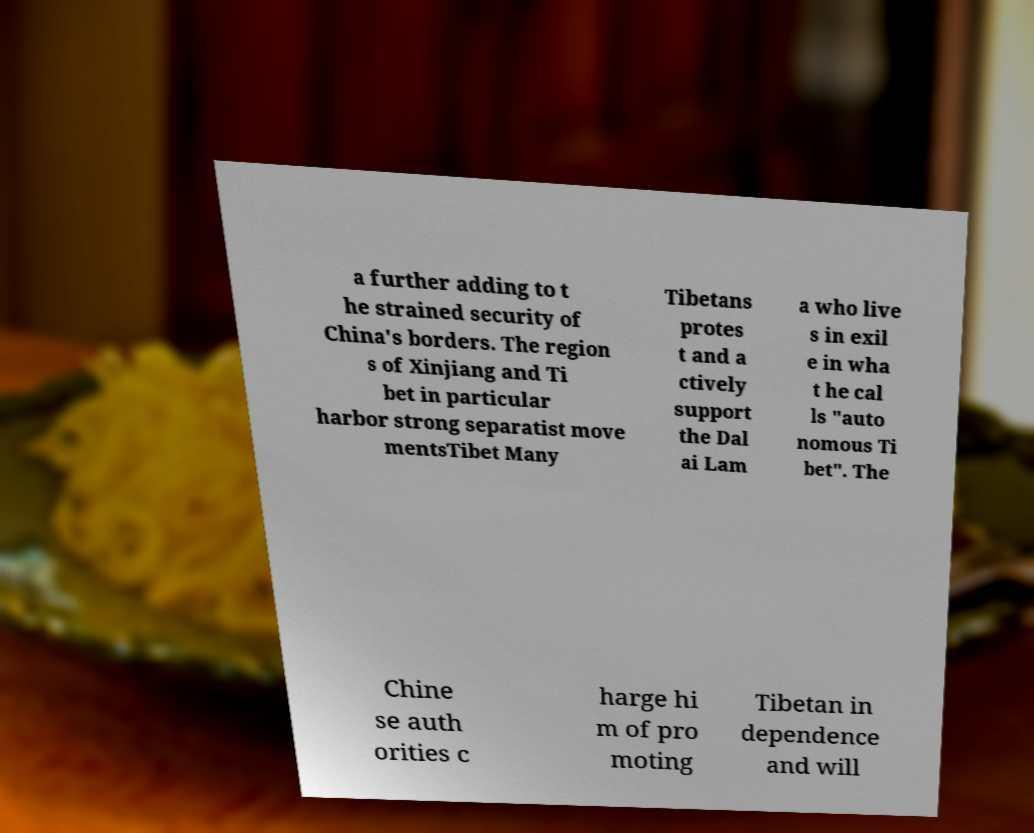Could you extract and type out the text from this image? a further adding to t he strained security of China's borders. The region s of Xinjiang and Ti bet in particular harbor strong separatist move mentsTibet Many Tibetans protes t and a ctively support the Dal ai Lam a who live s in exil e in wha t he cal ls "auto nomous Ti bet". The Chine se auth orities c harge hi m of pro moting Tibetan in dependence and will 